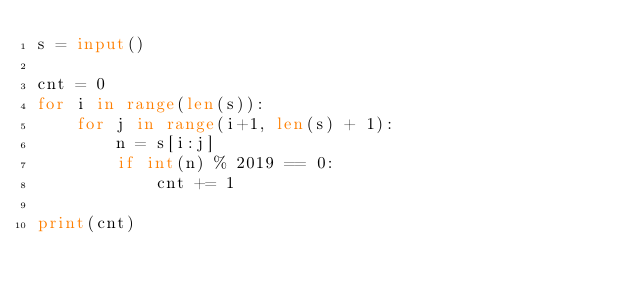Convert code to text. <code><loc_0><loc_0><loc_500><loc_500><_Python_>s = input()

cnt = 0
for i in range(len(s)):
    for j in range(i+1, len(s) + 1):
        n = s[i:j]
        if int(n) % 2019 == 0:
            cnt += 1

print(cnt)
</code> 